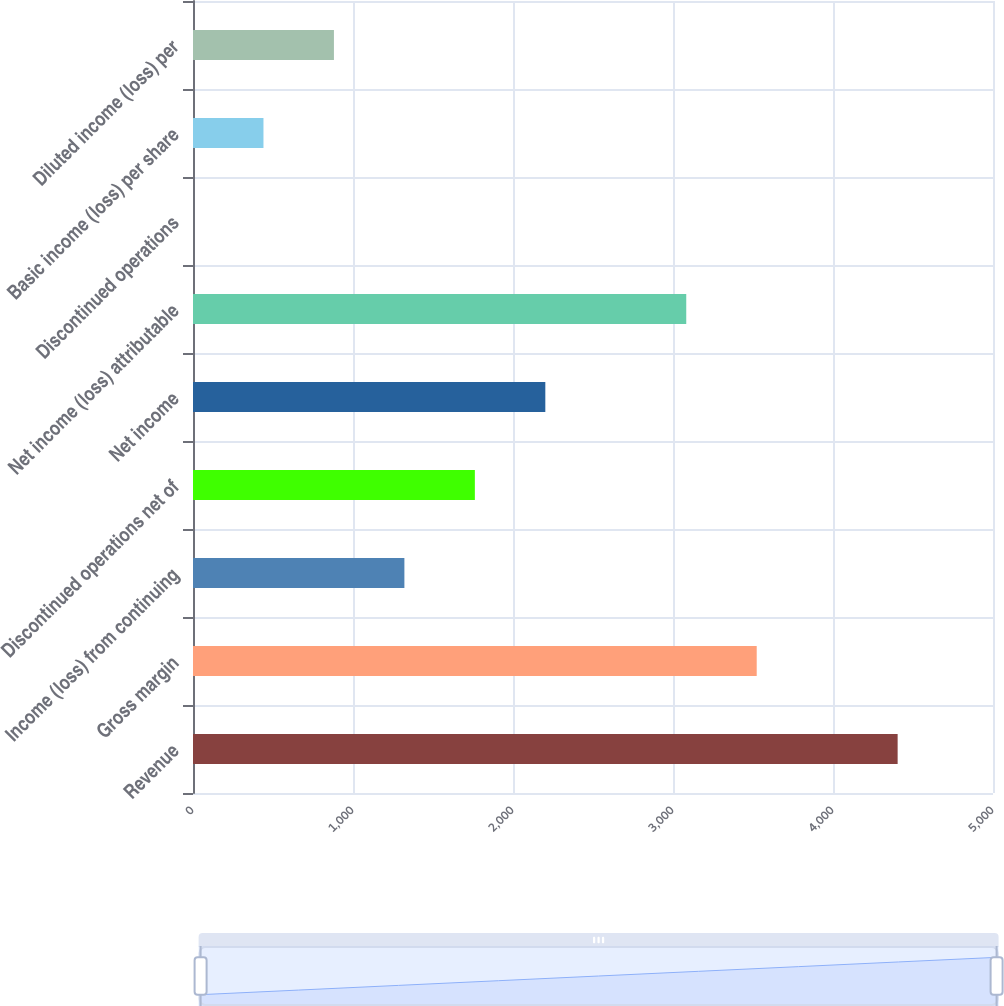<chart> <loc_0><loc_0><loc_500><loc_500><bar_chart><fcel>Revenue<fcel>Gross margin<fcel>Income (loss) from continuing<fcel>Discontinued operations net of<fcel>Net income<fcel>Net income (loss) attributable<fcel>Discontinued operations<fcel>Basic income (loss) per share<fcel>Diluted income (loss) per<nl><fcel>4404<fcel>3523.21<fcel>1321.21<fcel>1761.61<fcel>2202.01<fcel>3082.81<fcel>0.01<fcel>440.41<fcel>880.81<nl></chart> 